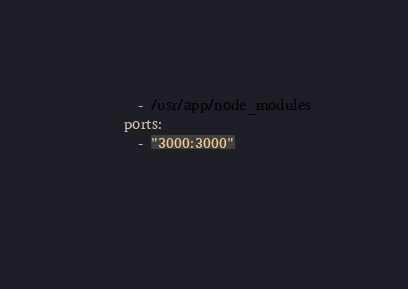<code> <loc_0><loc_0><loc_500><loc_500><_YAML_>      - /usr/app/node_modules
    ports:
      - "3000:3000"

  </code> 